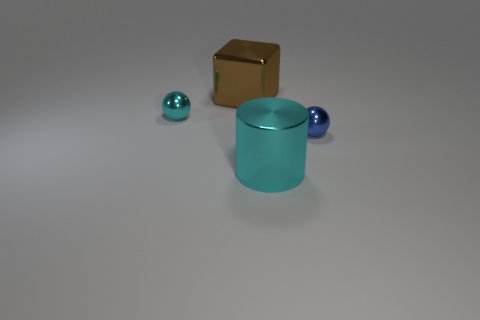Subtract all blue spheres. How many spheres are left? 1 Add 4 large shiny cubes. How many objects exist? 8 Subtract 0 yellow cylinders. How many objects are left? 4 Subtract 1 balls. How many balls are left? 1 Subtract all gray cylinders. Subtract all brown blocks. How many cylinders are left? 1 Subtract all cyan cylinders. How many gray cubes are left? 0 Subtract all large things. Subtract all large cyan metallic objects. How many objects are left? 1 Add 2 metal cylinders. How many metal cylinders are left? 3 Add 1 tiny blue spheres. How many tiny blue spheres exist? 2 